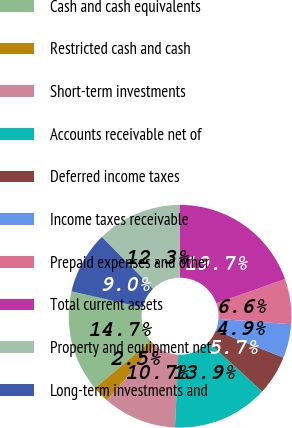<chart> <loc_0><loc_0><loc_500><loc_500><pie_chart><fcel>Cash and cash equivalents<fcel>Restricted cash and cash<fcel>Short-term investments<fcel>Accounts receivable net of<fcel>Deferred income taxes<fcel>Income taxes receivable<fcel>Prepaid expenses and other<fcel>Total current assets<fcel>Property and equipment net<fcel>Long-term investments and<nl><fcel>14.75%<fcel>2.46%<fcel>10.66%<fcel>13.93%<fcel>5.74%<fcel>4.92%<fcel>6.56%<fcel>19.67%<fcel>12.3%<fcel>9.02%<nl></chart> 